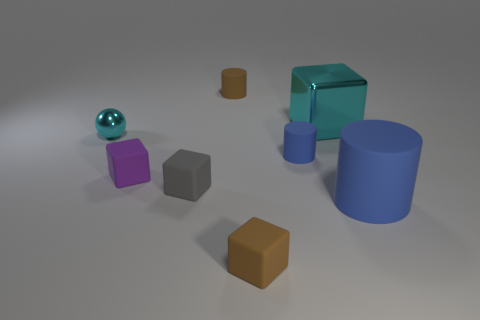How many objects are either green things or cylinders right of the small blue cylinder?
Give a very brief answer. 1. What is the size of the gray object that is made of the same material as the purple object?
Ensure brevity in your answer.  Small. There is a small brown matte thing right of the tiny thing behind the cyan ball; what is its shape?
Offer a very short reply. Cube. How many purple things are shiny balls or large matte things?
Provide a succinct answer. 0. There is a big object behind the blue matte object in front of the small purple rubber cube; are there any cyan shiny cubes that are right of it?
Provide a succinct answer. No. What is the shape of the small matte thing that is the same color as the large rubber object?
Provide a succinct answer. Cylinder. Is there anything else that is the same material as the big block?
Provide a short and direct response. Yes. How many big objects are either green cylinders or matte blocks?
Give a very brief answer. 0. Does the big thing to the left of the large cylinder have the same shape as the small cyan object?
Ensure brevity in your answer.  No. Are there fewer purple spheres than small cyan shiny things?
Offer a terse response. Yes. 